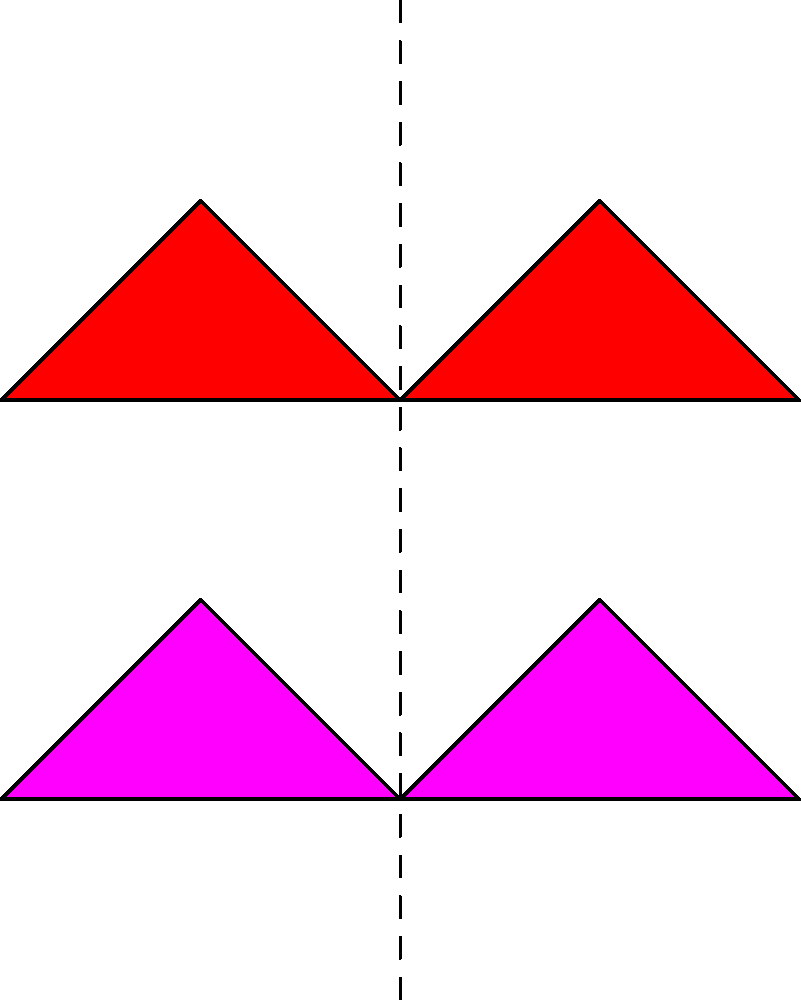In the diagram above, a simplified representation of heart chambers is reflected across a vertical axis. If the distance between the leftmost point of the left atrium and the axis of reflection is 2 units, what is the distance between the leftmost points of the original and reflected left atria? To solve this problem, we need to understand the properties of reflection:

1. The axis of reflection acts as a perpendicular bisector between any point and its reflection.
2. The distance from any point to the axis of reflection is equal to the distance from the reflected point to the axis.

Given:
- The distance between the leftmost point of the left atrium and the axis of reflection is 2 units.

Step 1: Visualize the reflection
The leftmost point of the original left atrium is 2 units to the left of the axis of reflection.
The leftmost point of the reflected left atrium will be 2 units to the right of the axis of reflection.

Step 2: Calculate the total distance
The total distance between the leftmost points of the original and reflected left atria is:
Distance = Distance to axis + Distance from axis
         = 2 units + 2 units
         = 4 units

Therefore, the distance between the leftmost points of the original and reflected left atria is 4 units.
Answer: 4 units 